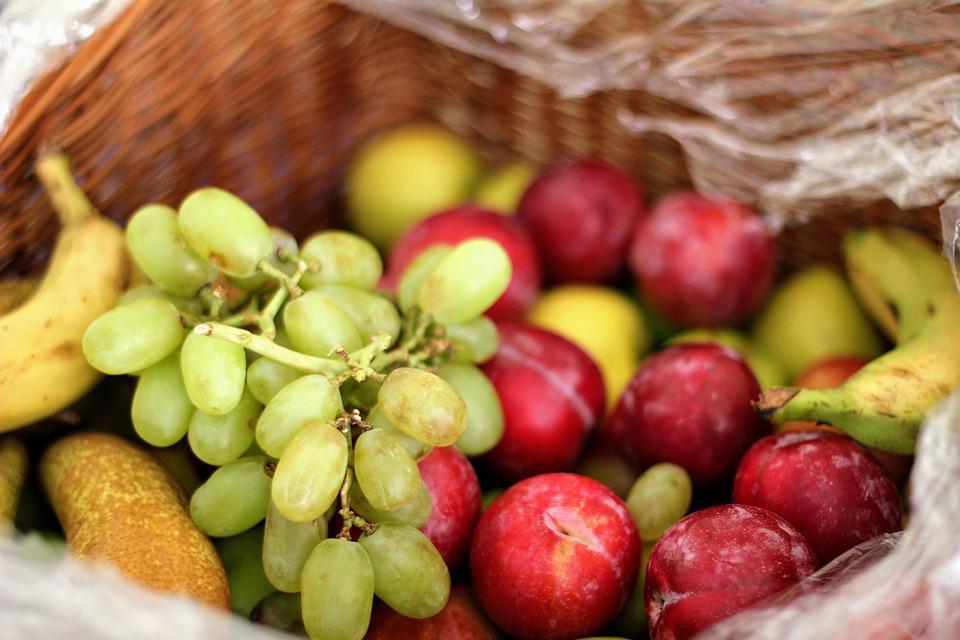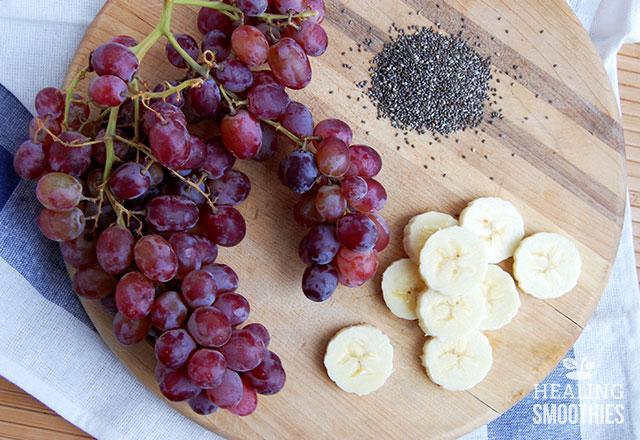The first image is the image on the left, the second image is the image on the right. Assess this claim about the two images: "There are some sliced bananas.". Correct or not? Answer yes or no. Yes. 